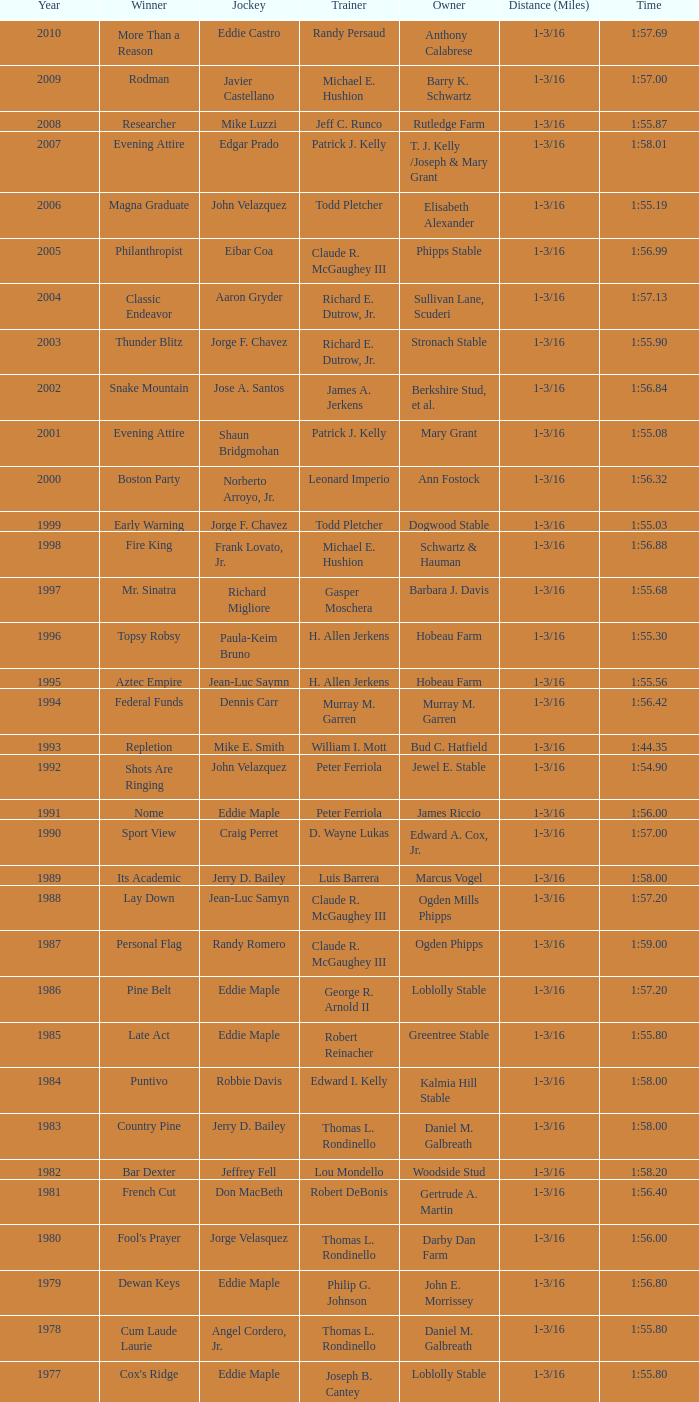When the winner was No Race in a year after 1909, what was the distance? 1 mile, 1 mile, 1 mile. 